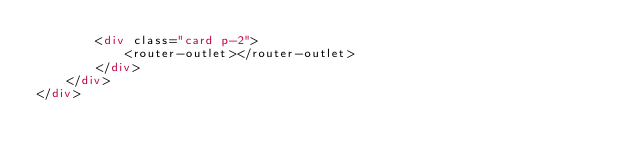Convert code to text. <code><loc_0><loc_0><loc_500><loc_500><_HTML_>        <div class="card p-2">
            <router-outlet></router-outlet>
        </div>
    </div>
</div>
</code> 